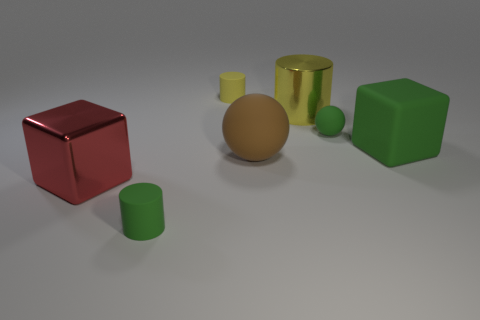Subtract all metal cylinders. How many cylinders are left? 2 Add 2 yellow cylinders. How many objects exist? 9 Subtract 1 spheres. How many spheres are left? 1 Subtract all green cylinders. How many cylinders are left? 2 Subtract all blocks. How many objects are left? 5 Subtract all yellow cylinders. How many green spheres are left? 1 Add 6 small green balls. How many small green balls are left? 7 Add 2 balls. How many balls exist? 4 Subtract 1 green balls. How many objects are left? 6 Subtract all red spheres. Subtract all brown cubes. How many spheres are left? 2 